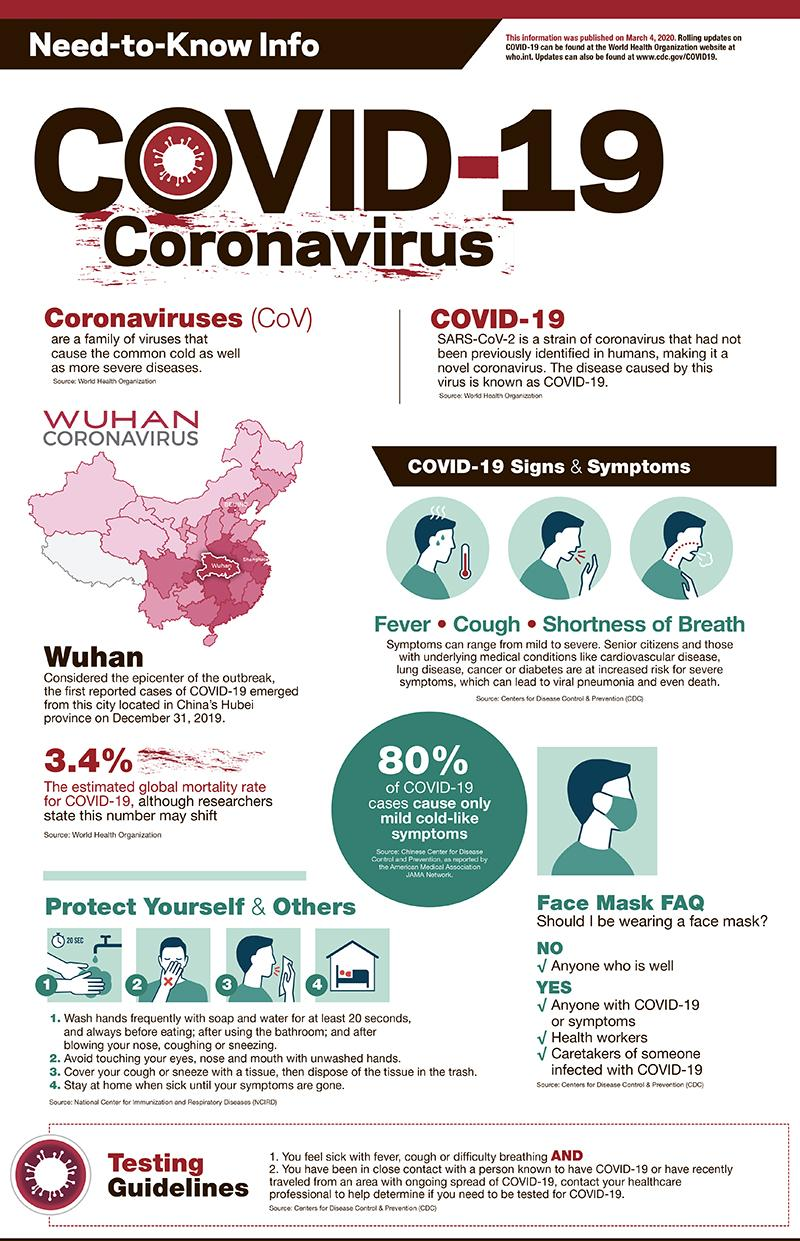Point out several critical features in this image. According to estimates, the global mortality rate for Covid-19 is currently 3.4%. According to recent reports, approximately 20% of COVID-19 cases result in severe symptoms. 